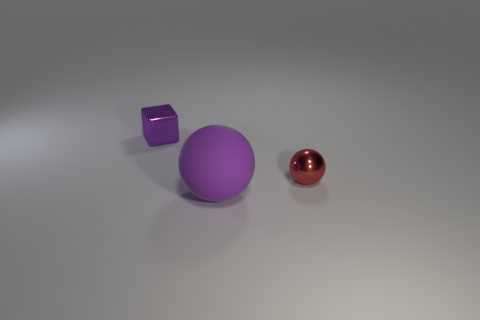Are there any gray cubes made of the same material as the tiny purple object?
Ensure brevity in your answer.  No. What number of things are either tiny metal things to the right of the big purple matte thing or small red metallic balls?
Offer a terse response. 1. Is the material of the purple object on the left side of the purple rubber thing the same as the tiny red ball?
Give a very brief answer. Yes. Is the shape of the small red object the same as the large thing?
Your response must be concise. Yes. What number of balls are in front of the purple thing that is behind the large rubber sphere?
Your response must be concise. 2. What material is the small thing that is the same shape as the large matte thing?
Offer a terse response. Metal. There is a thing on the left side of the large purple rubber object; does it have the same color as the large thing?
Your answer should be very brief. Yes. Is the big purple thing made of the same material as the tiny thing right of the metallic cube?
Ensure brevity in your answer.  No. There is a tiny metal object that is to the right of the large thing; what shape is it?
Make the answer very short. Sphere. How many other things are the same material as the small sphere?
Your answer should be very brief. 1. 